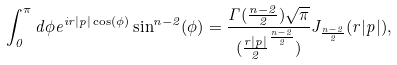<formula> <loc_0><loc_0><loc_500><loc_500>\int _ { 0 } ^ { \pi } d \phi e ^ { i r | p | \cos ( \phi ) } \sin ^ { n - 2 } ( \phi ) = \frac { \Gamma ( \frac { n - 2 } { 2 } ) \sqrt { \pi } } { ( \frac { r | p | } { 2 } ^ { \frac { n - 2 } { 2 } } ) } J _ { \frac { n - 2 } { 2 } } ( r | p | ) ,</formula> 